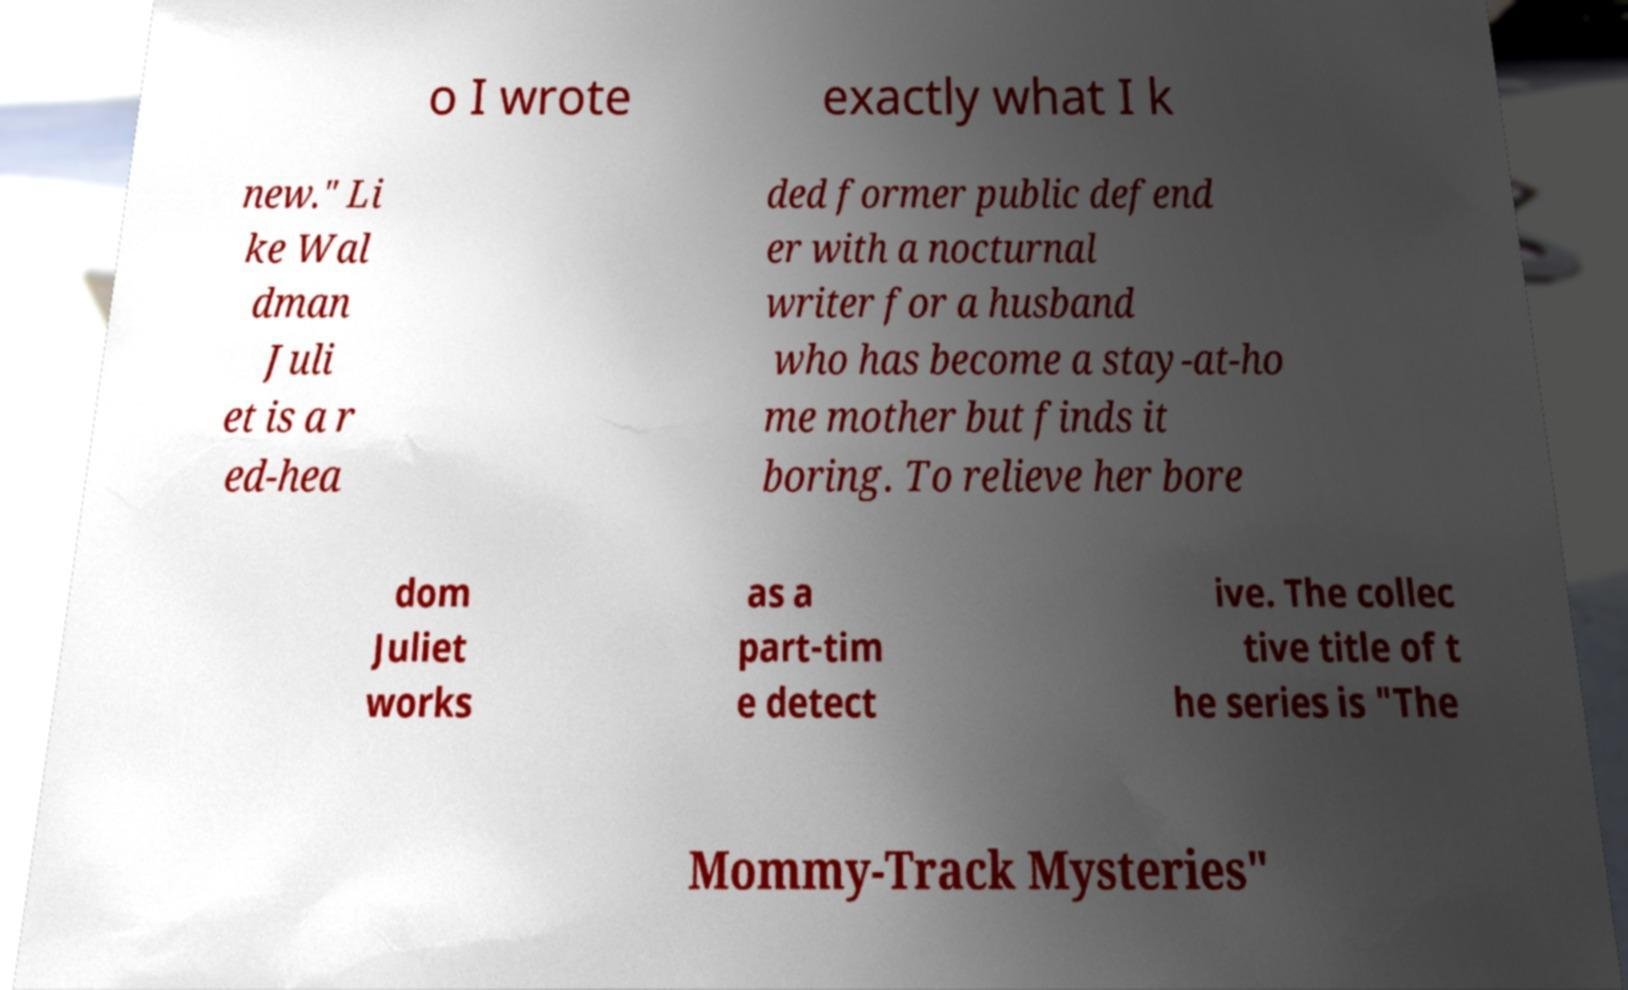There's text embedded in this image that I need extracted. Can you transcribe it verbatim? o I wrote exactly what I k new." Li ke Wal dman Juli et is a r ed-hea ded former public defend er with a nocturnal writer for a husband who has become a stay-at-ho me mother but finds it boring. To relieve her bore dom Juliet works as a part-tim e detect ive. The collec tive title of t he series is "The Mommy-Track Mysteries" 